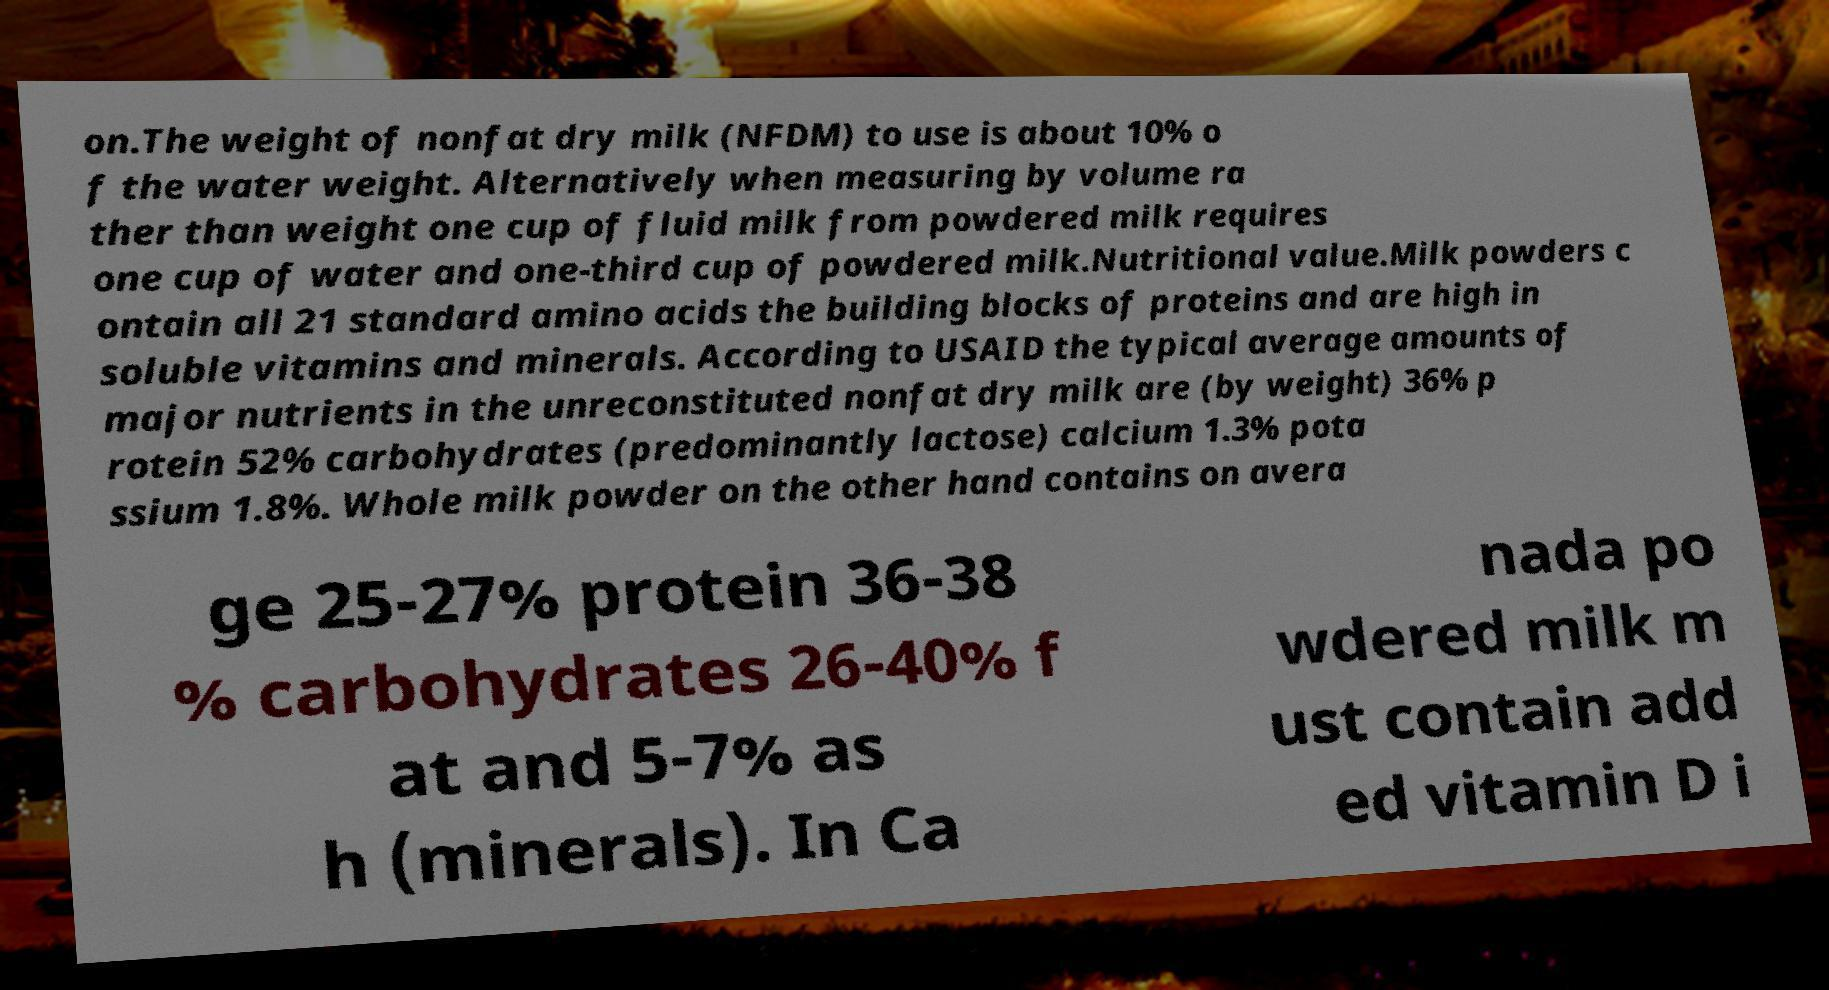Please read and relay the text visible in this image. What does it say? on.The weight of nonfat dry milk (NFDM) to use is about 10% o f the water weight. Alternatively when measuring by volume ra ther than weight one cup of fluid milk from powdered milk requires one cup of water and one-third cup of powdered milk.Nutritional value.Milk powders c ontain all 21 standard amino acids the building blocks of proteins and are high in soluble vitamins and minerals. According to USAID the typical average amounts of major nutrients in the unreconstituted nonfat dry milk are (by weight) 36% p rotein 52% carbohydrates (predominantly lactose) calcium 1.3% pota ssium 1.8%. Whole milk powder on the other hand contains on avera ge 25-27% protein 36-38 % carbohydrates 26-40% f at and 5-7% as h (minerals). In Ca nada po wdered milk m ust contain add ed vitamin D i 